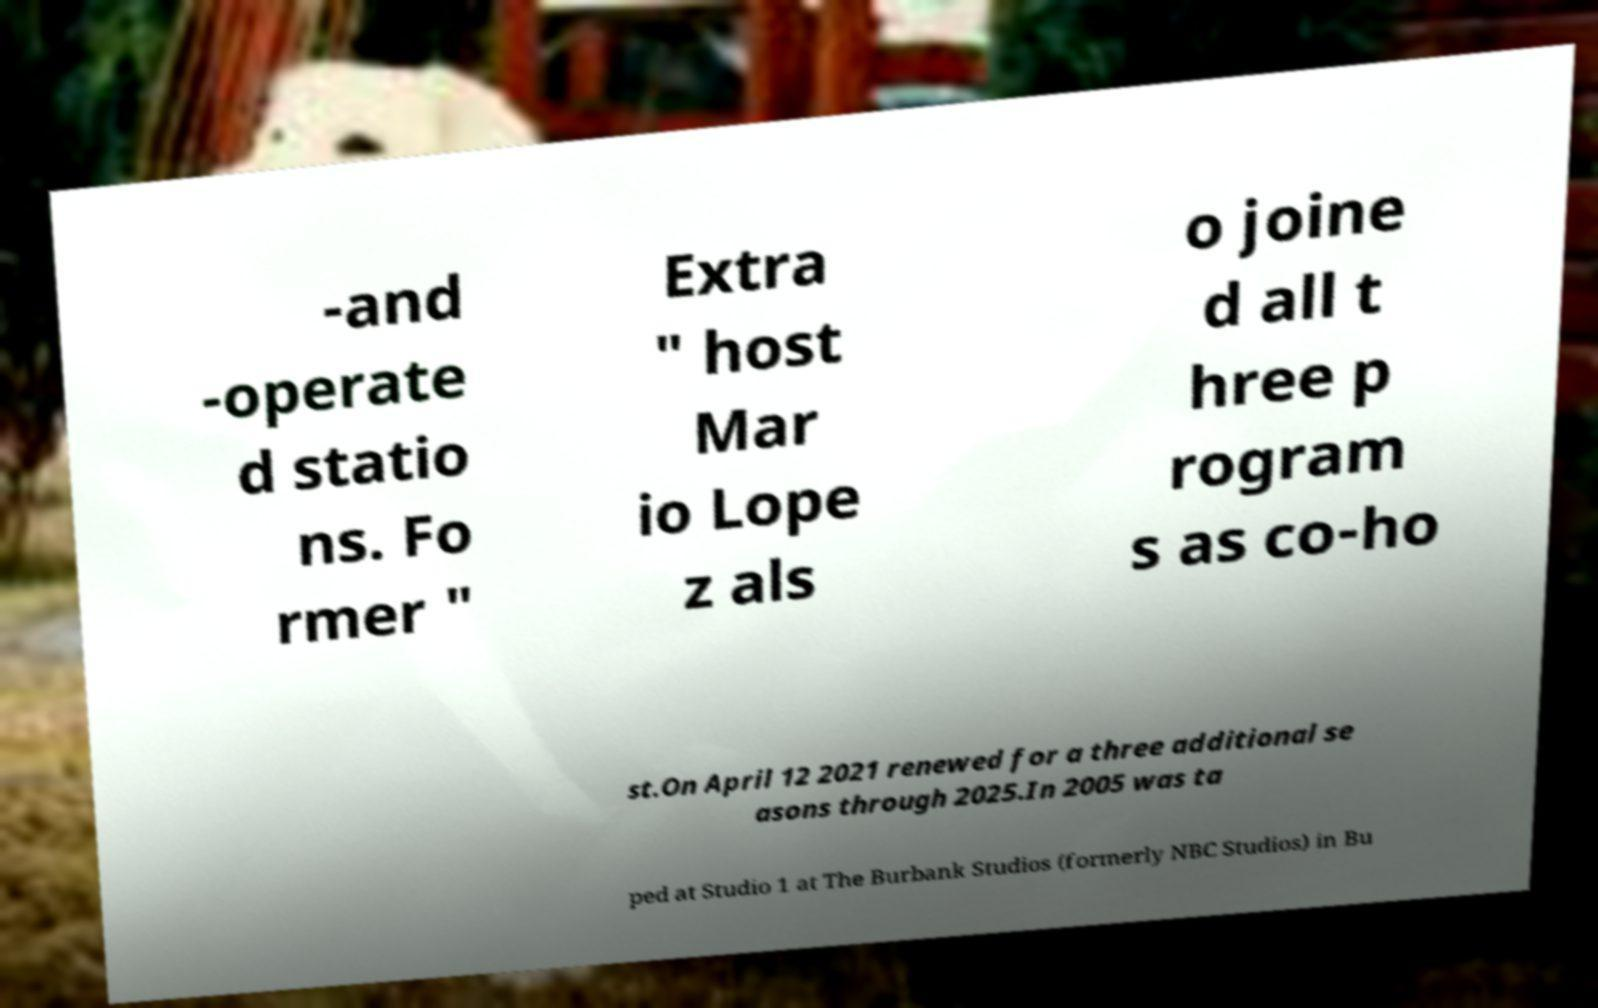There's text embedded in this image that I need extracted. Can you transcribe it verbatim? -and -operate d statio ns. Fo rmer " Extra " host Mar io Lope z als o joine d all t hree p rogram s as co-ho st.On April 12 2021 renewed for a three additional se asons through 2025.In 2005 was ta ped at Studio 1 at The Burbank Studios (formerly NBC Studios) in Bu 